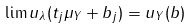<formula> <loc_0><loc_0><loc_500><loc_500>\lim u _ { \lambda } ( t _ { j } \mu _ { Y } + b _ { j } ) = u _ { Y } ( b )</formula> 